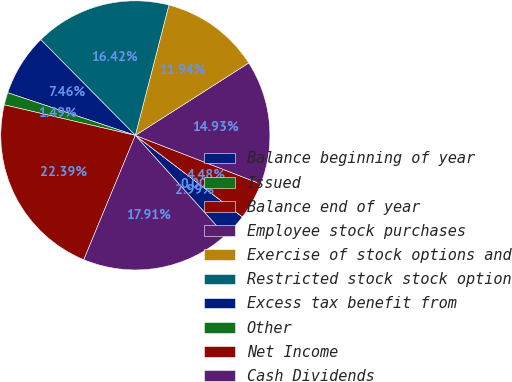Convert chart to OTSL. <chart><loc_0><loc_0><loc_500><loc_500><pie_chart><fcel>Balance beginning of year<fcel>Issued<fcel>Balance end of year<fcel>Employee stock purchases<fcel>Exercise of stock options and<fcel>Restricted stock stock option<fcel>Excess tax benefit from<fcel>Other<fcel>Net Income<fcel>Cash Dividends<nl><fcel>2.99%<fcel>0.0%<fcel>4.48%<fcel>14.93%<fcel>11.94%<fcel>16.42%<fcel>7.46%<fcel>1.49%<fcel>22.39%<fcel>17.91%<nl></chart> 